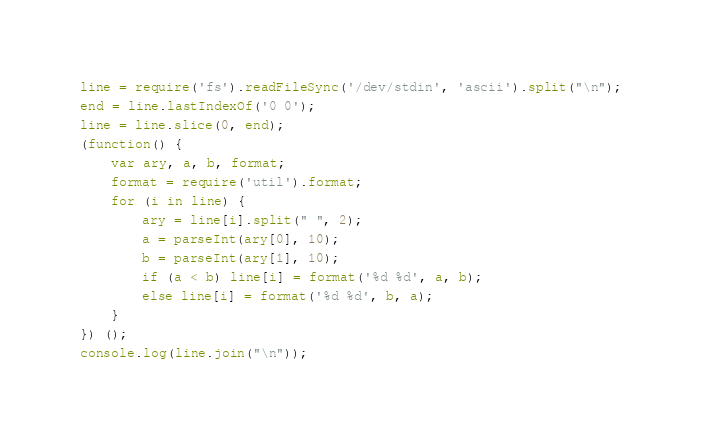<code> <loc_0><loc_0><loc_500><loc_500><_JavaScript_>line = require('fs').readFileSync('/dev/stdin', 'ascii').split("\n");
end = line.lastIndexOf('0 0');
line = line.slice(0, end);
(function() {
	var ary, a, b, format;
	format = require('util').format;
	for (i in line) {
		ary = line[i].split(" ", 2);
		a = parseInt(ary[0], 10);
		b = parseInt(ary[1], 10);
		if (a < b) line[i] = format('%d %d', a, b);
		else line[i] = format('%d %d', b, a);
	}
}) ();
console.log(line.join("\n"));</code> 